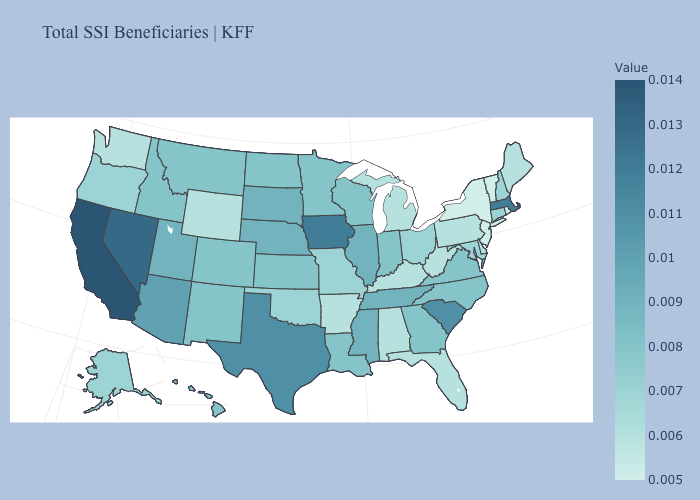Which states have the lowest value in the West?
Write a very short answer. Washington, Wyoming. Among the states that border Colorado , which have the lowest value?
Concise answer only. Wyoming. Does the map have missing data?
Give a very brief answer. No. Which states have the lowest value in the USA?
Be succinct. New Jersey, New York, Rhode Island, Vermont. Among the states that border Massachusetts , does New Hampshire have the lowest value?
Answer briefly. No. Does South Carolina have the highest value in the South?
Short answer required. Yes. Does Kentucky have a higher value than Tennessee?
Be succinct. No. Among the states that border California , does Nevada have the highest value?
Be succinct. Yes. Which states hav the highest value in the MidWest?
Answer briefly. Iowa. 